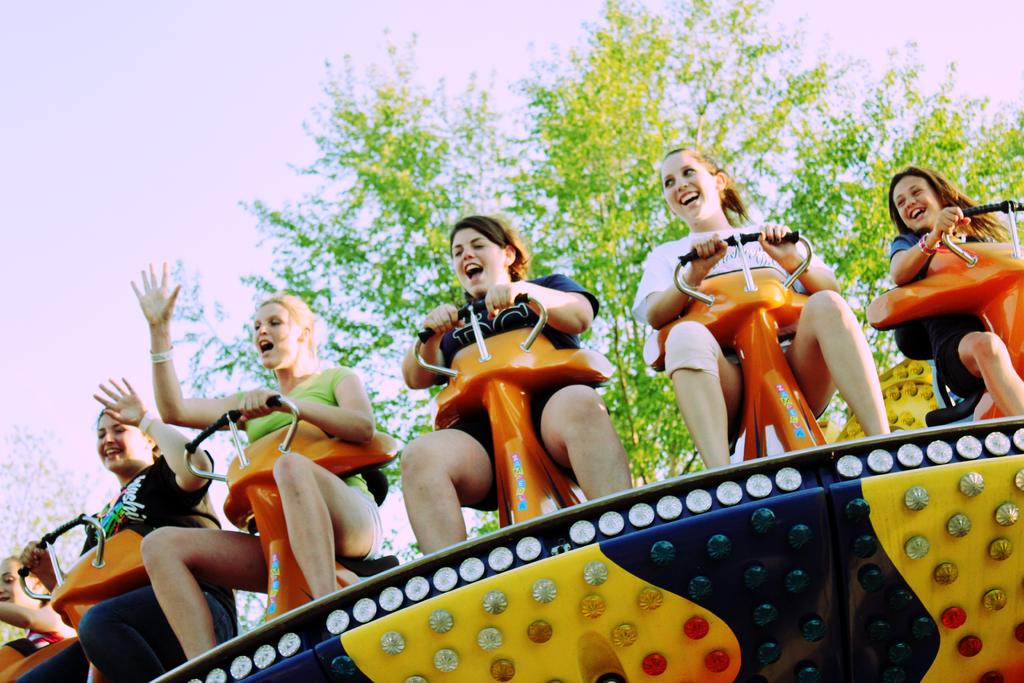What are the women doing in the image? The women are sitting on a vehicle and enjoying themselves. What can be seen in the background of the image? There is a tree and the sky visible at the top of the image. What type of haircut does the tree have in the image? There is no haircut present in the image, as the tree is a natural object and does not have hair. 